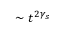<formula> <loc_0><loc_0><loc_500><loc_500>\sim t ^ { 2 \gamma _ { s } }</formula> 